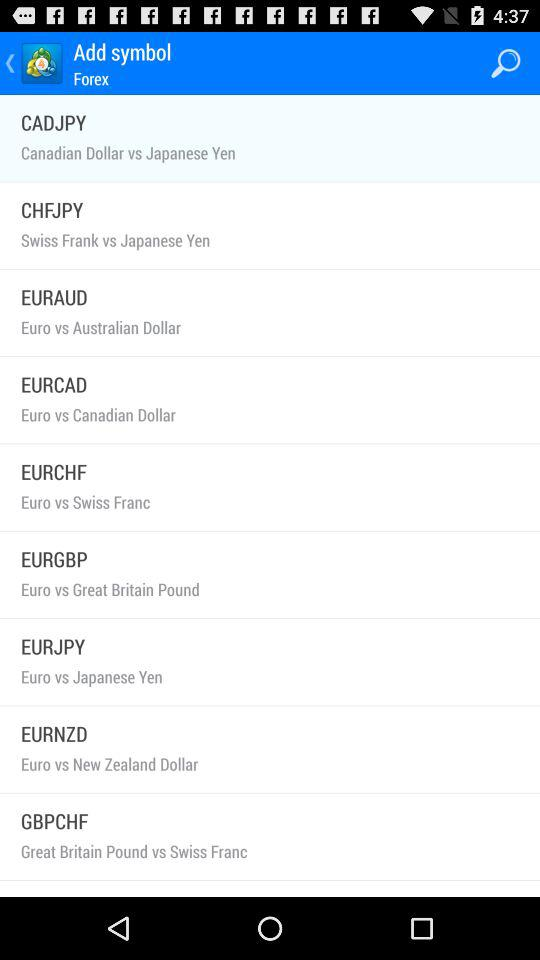What is the symbol for Euro vs Australian Dollar? The symbol is EURAUD. 